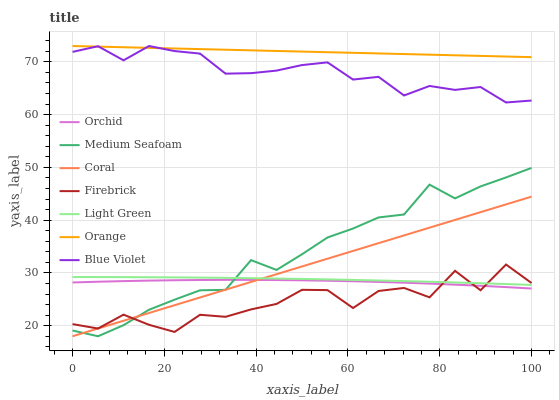Does Firebrick have the minimum area under the curve?
Answer yes or no. Yes. Does Orange have the maximum area under the curve?
Answer yes or no. Yes. Does Medium Seafoam have the minimum area under the curve?
Answer yes or no. No. Does Medium Seafoam have the maximum area under the curve?
Answer yes or no. No. Is Orange the smoothest?
Answer yes or no. Yes. Is Firebrick the roughest?
Answer yes or no. Yes. Is Medium Seafoam the smoothest?
Answer yes or no. No. Is Medium Seafoam the roughest?
Answer yes or no. No. Does Medium Seafoam have the lowest value?
Answer yes or no. Yes. Does Light Green have the lowest value?
Answer yes or no. No. Does Blue Violet have the highest value?
Answer yes or no. Yes. Does Medium Seafoam have the highest value?
Answer yes or no. No. Is Orchid less than Orange?
Answer yes or no. Yes. Is Blue Violet greater than Orchid?
Answer yes or no. Yes. Does Orchid intersect Coral?
Answer yes or no. Yes. Is Orchid less than Coral?
Answer yes or no. No. Is Orchid greater than Coral?
Answer yes or no. No. Does Orchid intersect Orange?
Answer yes or no. No. 